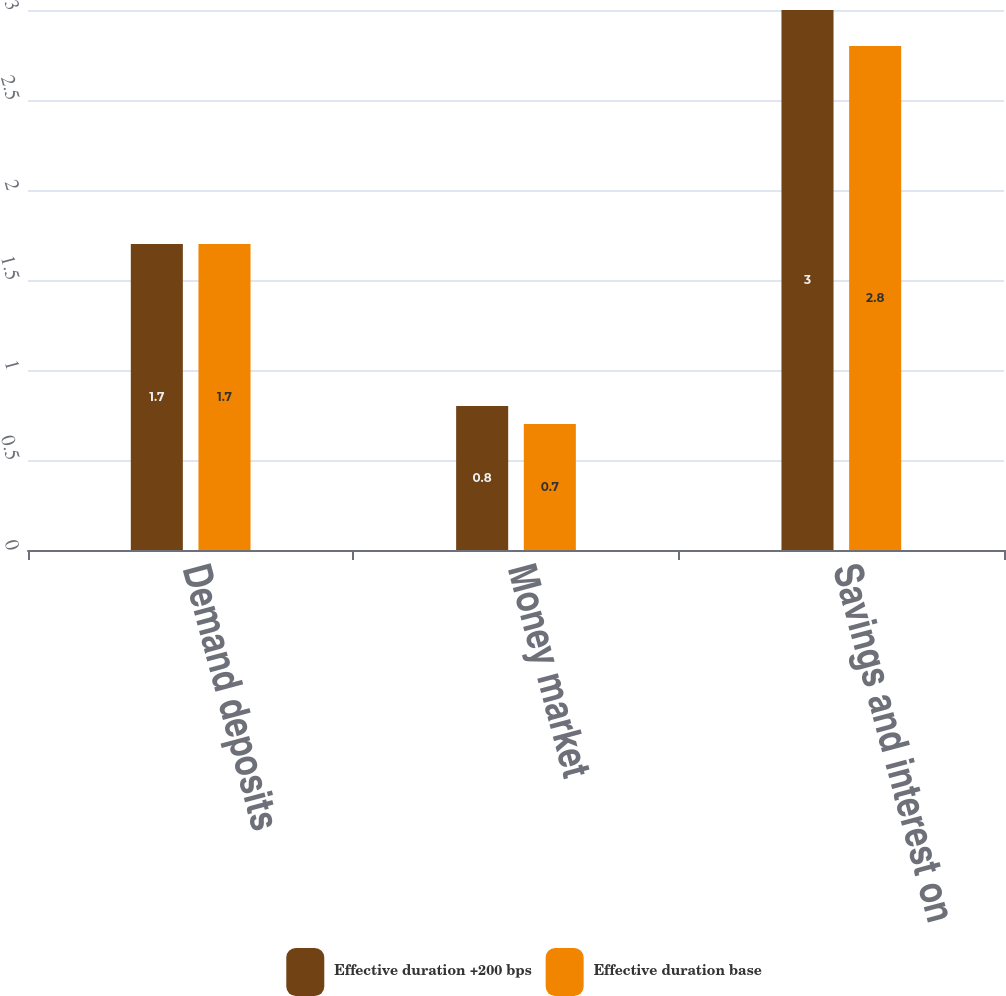<chart> <loc_0><loc_0><loc_500><loc_500><stacked_bar_chart><ecel><fcel>Demand deposits<fcel>Money market<fcel>Savings and interest on<nl><fcel>Effective duration +200 bps<fcel>1.7<fcel>0.8<fcel>3<nl><fcel>Effective duration base<fcel>1.7<fcel>0.7<fcel>2.8<nl></chart> 